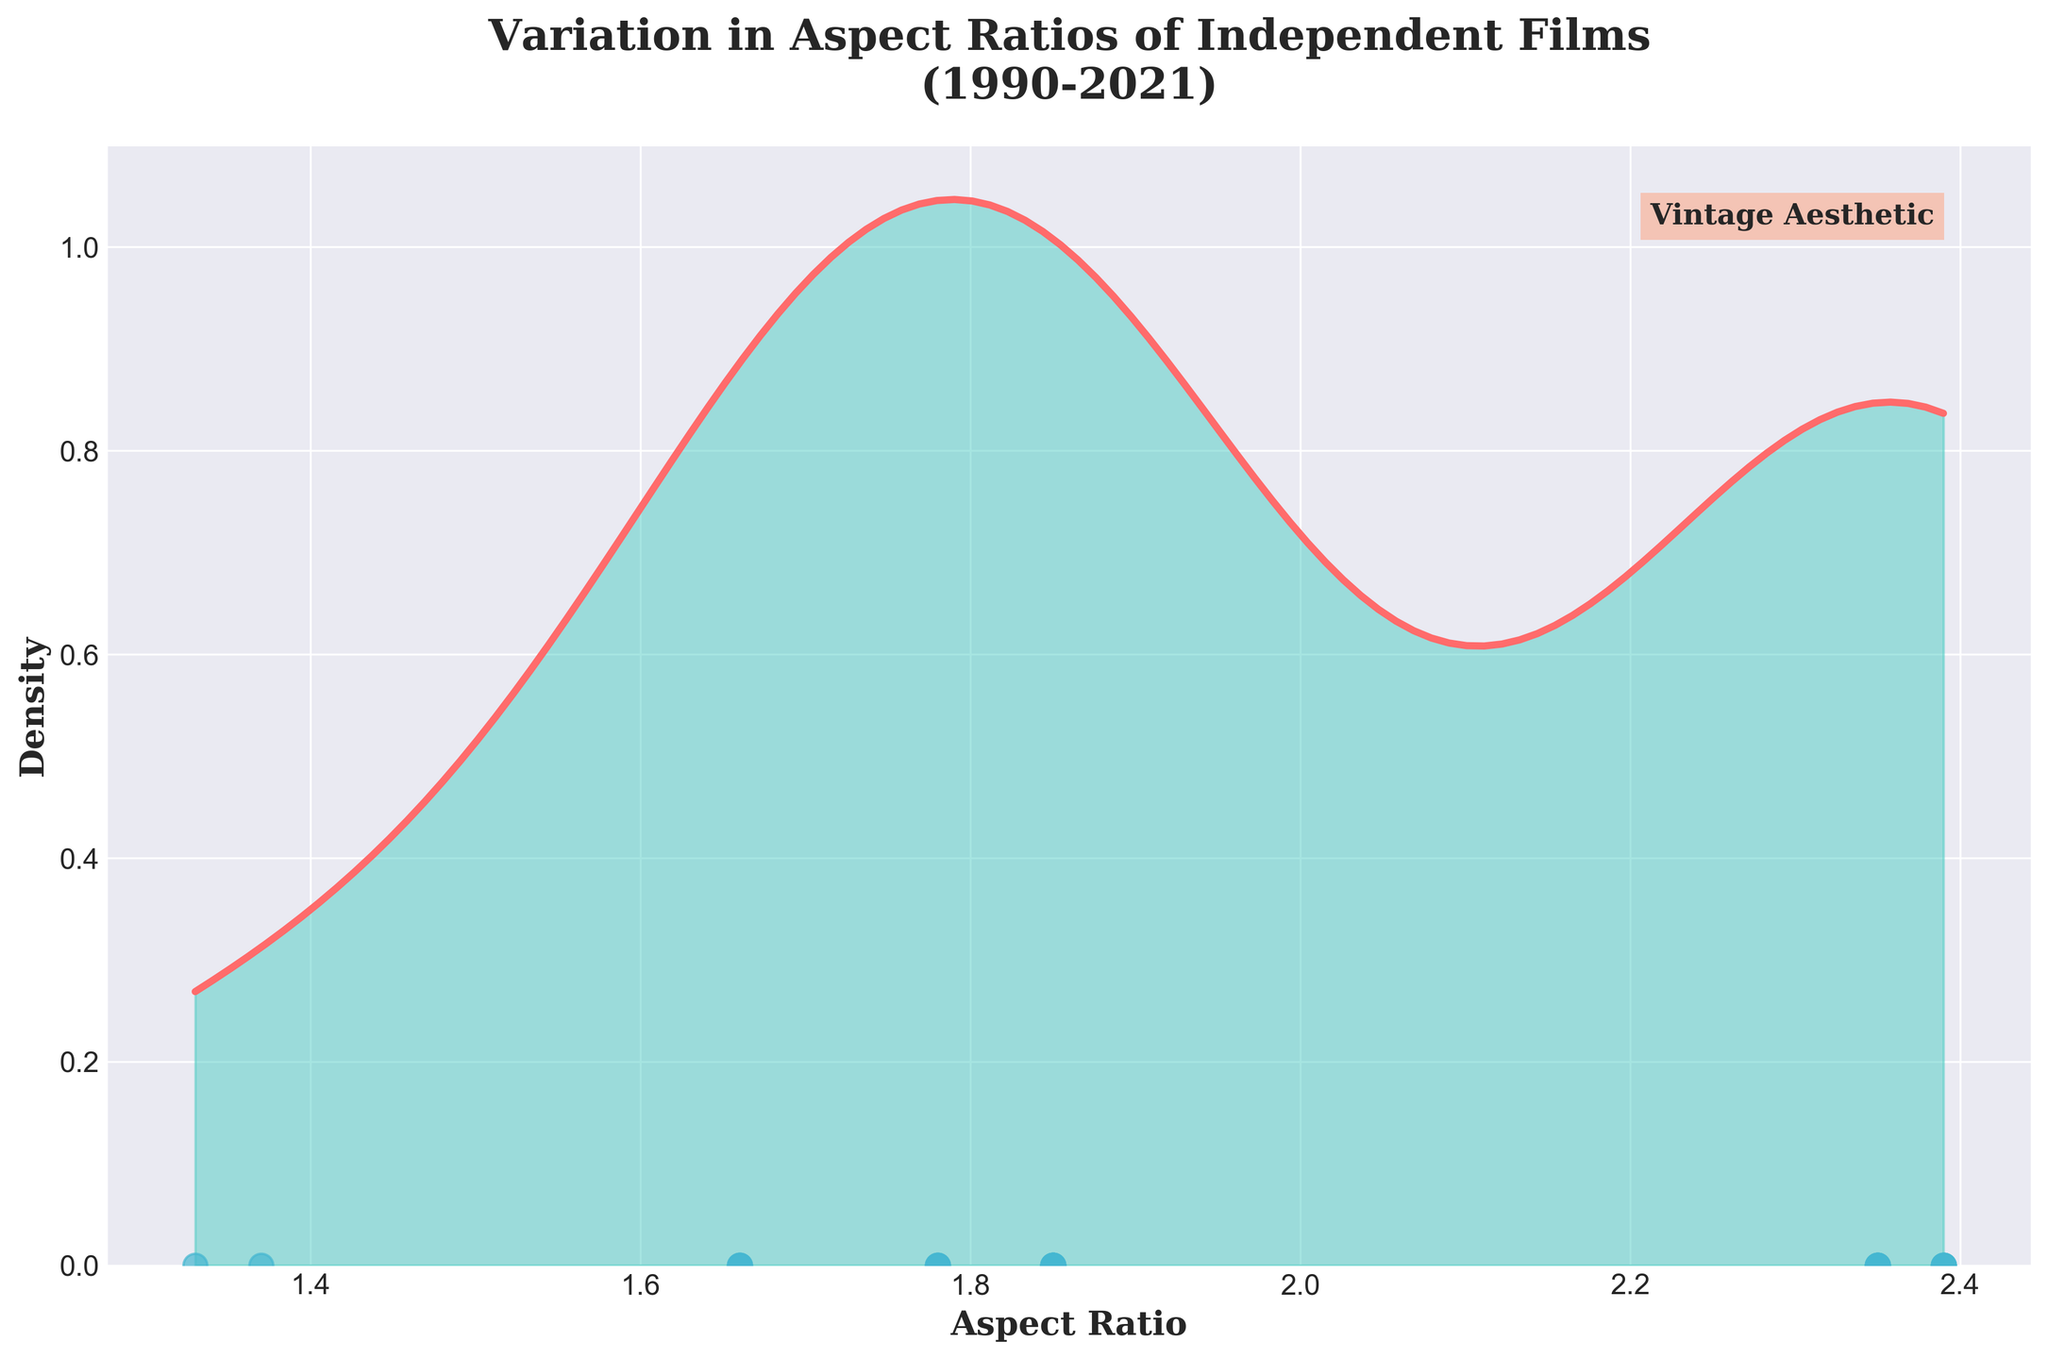What is the title of the plot? The title of the plot is displayed prominently at the top. It reads "Variation in Aspect Ratios of Independent Films (1990-2021)."
Answer: Variation in Aspect Ratios of Independent Films (1990-2021) What does the x-axis represent? The x-axis of the plot is labeled "Aspect Ratio," indicating that it represents different aspect ratios of films.
Answer: Aspect Ratio What color is used for the density plot line? The density plot line is drawn in a prominent color for easy visualization. The color used is a shade of red.
Answer: Red How many data points have an aspect ratio of 2.35? The plot shows aspect ratio data points marked as scattered dots. By visually counting, there are five dots aligned with an aspect ratio of 2.35.
Answer: 5 Which aspect ratio appears most frequently in the density plot? The peak of the density curve indicates the most frequent value. The tallest peak is around 1.85.
Answer: 1.85 What is the lowest aspect ratio shown in the plot? The x-axis shows a range of aspect ratios, and the lowest value indicated on the x-axis is around 1.33.
Answer: 1.33 Is there a data point with an aspect ratio of 1.37? The scatter plot along the x-axis shows data points. One dot is located at 1.37, confirming its presence.
Answer: Yes Compare the density of aspect ratios 1.85 and 2.39. Which one is more frequent? The density curve's height for 1.85 is higher than that for 2.39, indicating that 1.85 is more frequent.
Answer: 1.85 What is the difference between the highest and lowest aspect ratios shown? The highest aspect ratio is around 2.39, and the lowest aspect ratio is 1.33. The difference is calculated as 2.39 - 1.33.
Answer: 1.06 Does the plot indicate any value for the year of the films? The plot's x-axis and density focus solely on aspect ratios and do not show any years. Visual inspection confirms there is no year data plotted on the figure.
Answer: No 